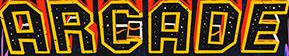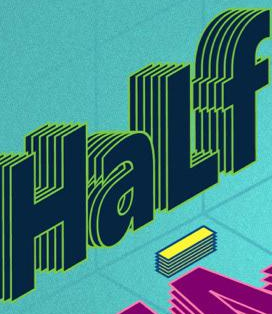Read the text from these images in sequence, separated by a semicolon. ARGADE; HaLf 